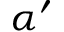<formula> <loc_0><loc_0><loc_500><loc_500>\alpha ^ { \prime }</formula> 